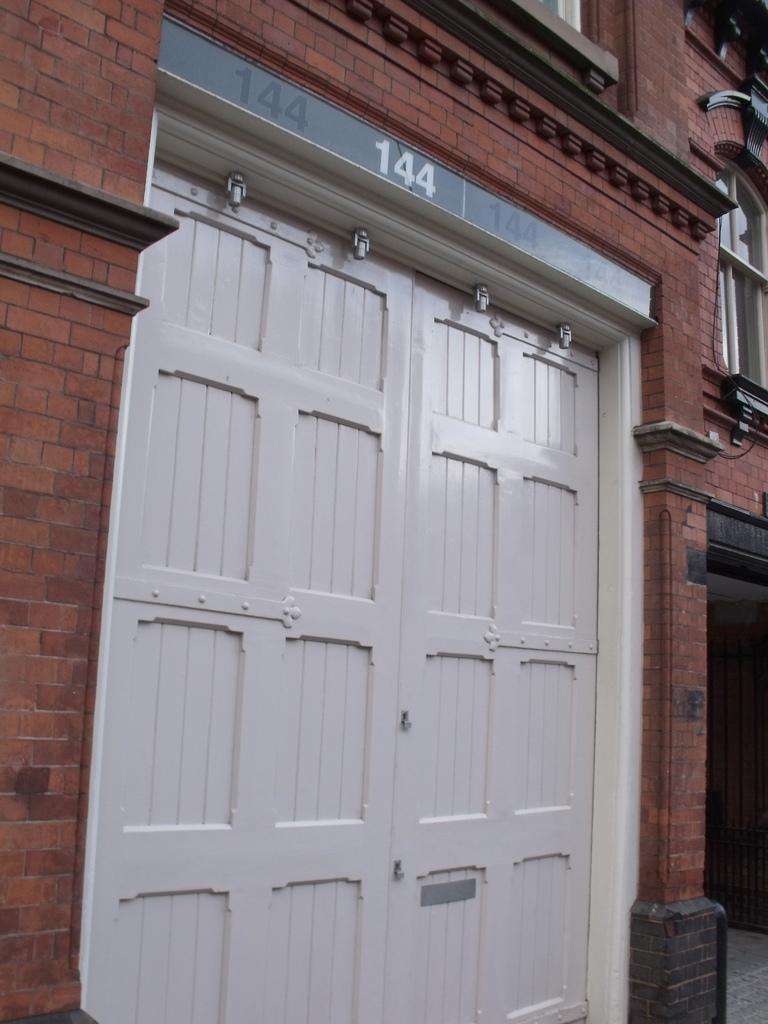What type of structure is visible in the image? There is a building in the image. What features can be observed on the building? The building has doors, a glass window, and a brick wall. What is located on the right side of the image? There is a grill and a footpath on the right side of the image. How many chairs are placed around the grill in the image? There are no chairs visible in the image; only a grill and a footpath are present on the right side. 